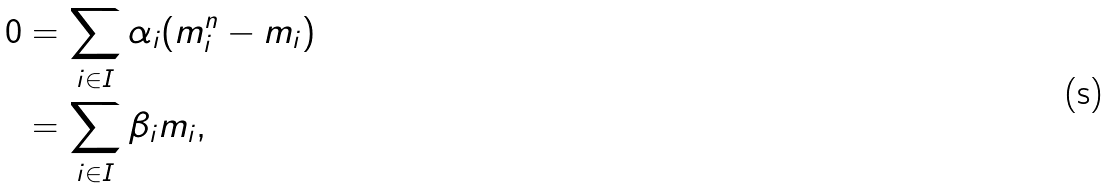<formula> <loc_0><loc_0><loc_500><loc_500>0 & = \sum _ { i \in I } \alpha _ { i } ( m _ { i } ^ { n } - m _ { i } ) \\ & = \sum _ { i \in I } \beta _ { i } m _ { i } ,</formula> 